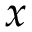<formula> <loc_0><loc_0><loc_500><loc_500>x</formula> 